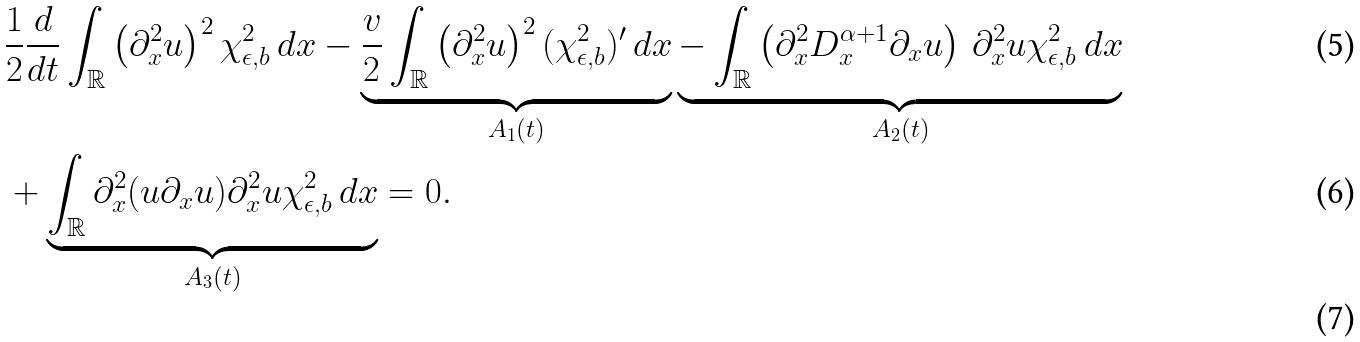Convert formula to latex. <formula><loc_0><loc_0><loc_500><loc_500>& \frac { 1 } { 2 } \frac { d } { d t } \int _ { \mathbb { R } } \left ( \partial _ { x } ^ { 2 } u \right ) ^ { 2 } \chi _ { \epsilon , b } ^ { 2 } \, d x - \underbrace { \frac { v } { 2 } \int _ { \mathbb { R } } \left ( \partial _ { x } ^ { 2 } u \right ) ^ { 2 } ( \chi _ { \epsilon , b } ^ { 2 } ) ^ { \prime } \, d x } _ { A _ { 1 } ( t ) } \underbrace { - \int _ { \mathbb { R } } \left ( \partial _ { x } ^ { 2 } D _ { x } ^ { \alpha + 1 } \partial _ { x } u \right ) \, \partial _ { x } ^ { 2 } u \chi _ { \epsilon , b } ^ { 2 } \, d x } _ { A _ { 2 } ( t ) } \\ & + \underbrace { \int _ { \mathbb { R } } \partial _ { x } ^ { 2 } ( u \partial _ { x } u ) \partial _ { x } ^ { 2 } u \chi _ { \epsilon , b } ^ { 2 } \, d x } _ { A _ { 3 } ( t ) } = 0 . \\</formula> 